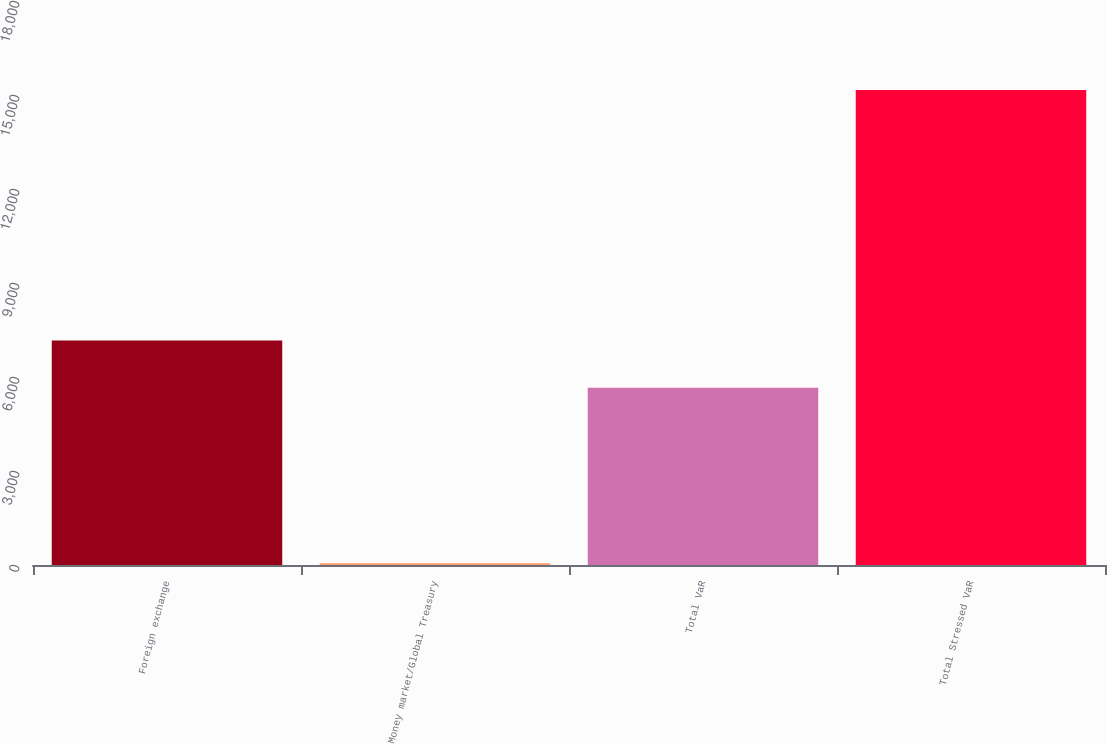<chart> <loc_0><loc_0><loc_500><loc_500><bar_chart><fcel>Foreign exchange<fcel>Money market/Global Treasury<fcel>Total VaR<fcel>Total Stressed VaR<nl><fcel>7167.4<fcel>53<fcel>5657<fcel>15157<nl></chart> 